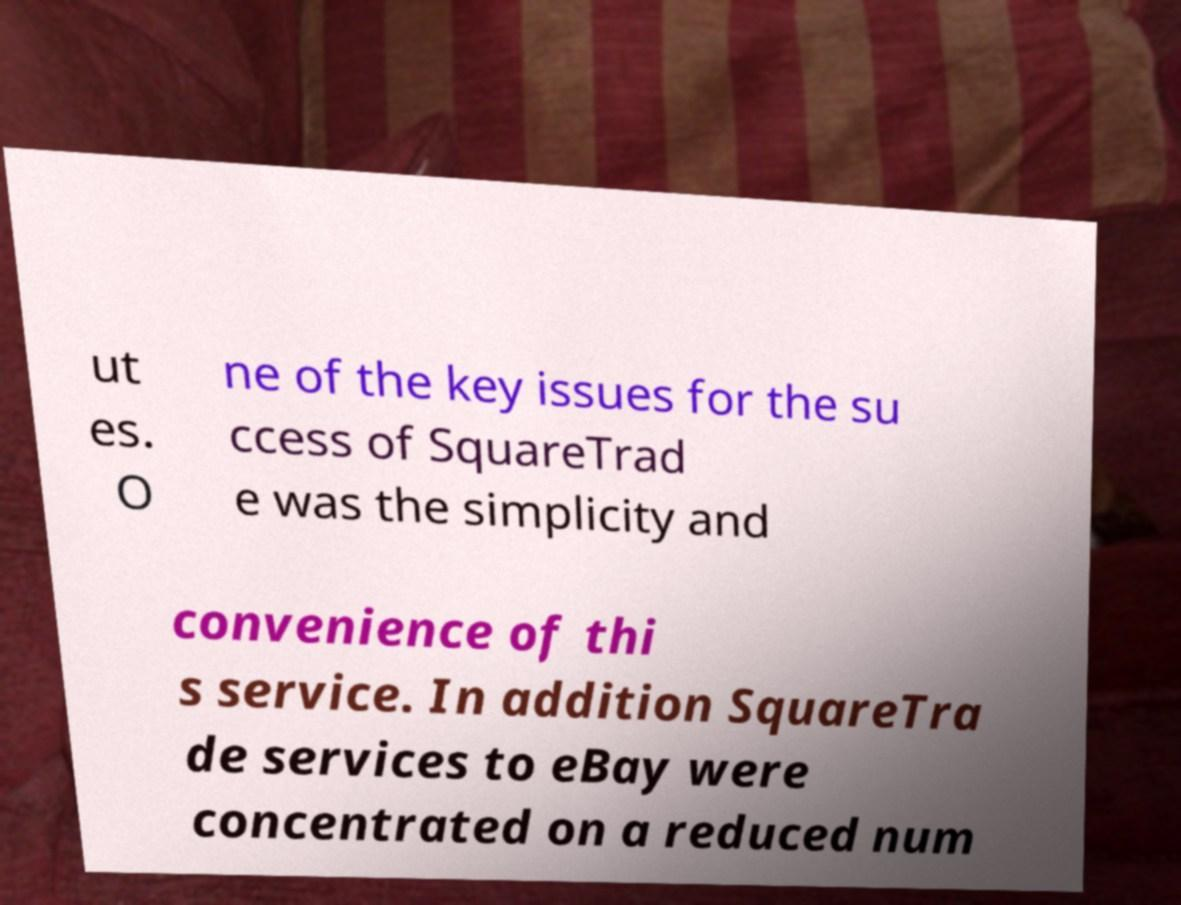Can you read and provide the text displayed in the image?This photo seems to have some interesting text. Can you extract and type it out for me? ut es. O ne of the key issues for the su ccess of SquareTrad e was the simplicity and convenience of thi s service. In addition SquareTra de services to eBay were concentrated on a reduced num 